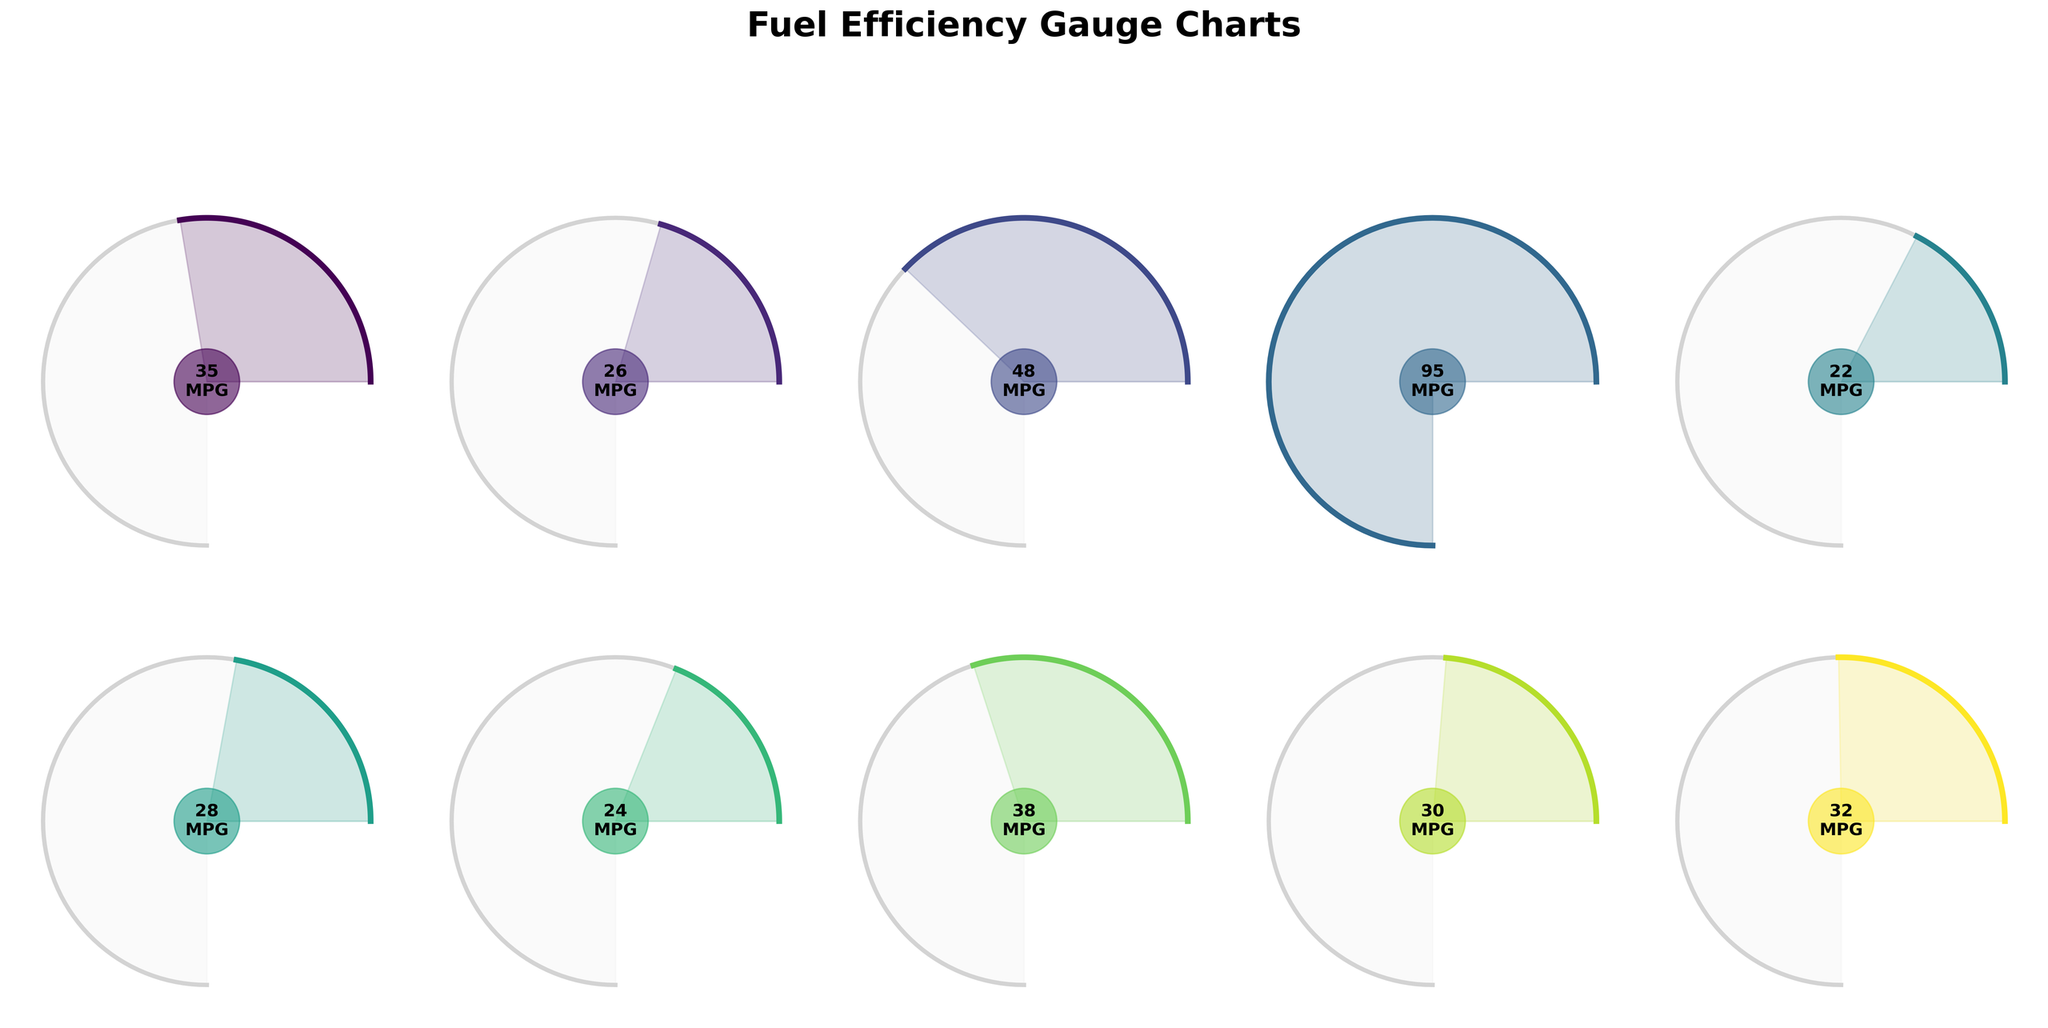What is the highest fuel efficiency value displayed for any vehicle type? The highest fuel efficiency value is marked on the plot for the "Electric" vehicle. The value shown is 95 MPG.
Answer: 95 MPG Which two vehicle types have the closest fuel efficiency values? By visually comparing the lengths of the gauge arcs, the "Minivan" and "Crossover" have fuel efficiency values that are close to each other. The values are 28 MPG and 32 MPG respectively, with only a 4 MPG difference.
Answer: Minivan and Crossover What is the average fuel efficiency of all vehicle types? Sum all the MPG values shown in the gauge charts: (35 + 26 + 48 + 95 + 22 + 28 + 24 + 38 + 30 + 32) = 378. Then divide by the number of vehicle types: 378 / 10 = 37.8 MPG.
Answer: 37.8 MPG Which vehicle type has the lowest fuel efficiency? The shortest arc on the gauge charts corresponds to the "Pickup Truck," indicating the lowest fuel efficiency of 22 MPG.
Answer: Pickup Truck How much more fuel efficient is the "Hybrid" vehicle compared to the "Sports Car"? The fuel efficiency of the "Hybrid" vehicle is 48 MPG, while the "Sports Car" has 24 MPG. Calculate the difference: 48 - 24 = 24 MPG.
Answer: 24 MPG What is the median fuel efficiency value among all vehicle types? First, list all fuel efficiencies in ascending order: 22, 24, 26, 28, 30, 32, 35, 38, 48, 95. Since there are 10 values, the median is the average of the 5th and 6th values. So, (30 + 32) / 2 = 31 MPG.
Answer: 31 MPG What is the range of fuel efficiencies shown in the gauge charts? The range is the difference between the highest and lowest fuel efficiency values: 95 MPG (Electric) - 22 MPG (Pickup Truck) = 73 MPG.
Answer: 73 MPG Which vehicle type is more fuel efficient: "Luxury Sedan" or "Compact Car," and by how much? "Compact Car" has a fuel efficiency of 38 MPG, while "Luxury Sedan" has 30 MPG. Calculate the difference: 38 - 30 = 8 MPG.
Answer: Compact Car, by 8 MPG Among "Sedan," "SUV," and "Crossover," which has the best fuel efficiency? By comparing the arcs, "Sedan" has 35 MPG, "SUV" has 26 MPG, and "Crossover" has 32 MPG. Therefore, "Sedan" has the best fuel efficiency among them.
Answer: Sedan How does the fuel efficiency of the "Sports Car" compare to the overall average fuel efficiency? The overall average fuel efficiency is 37.8 MPG. The "Sports Car" has 24 MPG. The difference is 37.8 - 24 = 13.8 MPG lower.
Answer: 13.8 MPG lower 